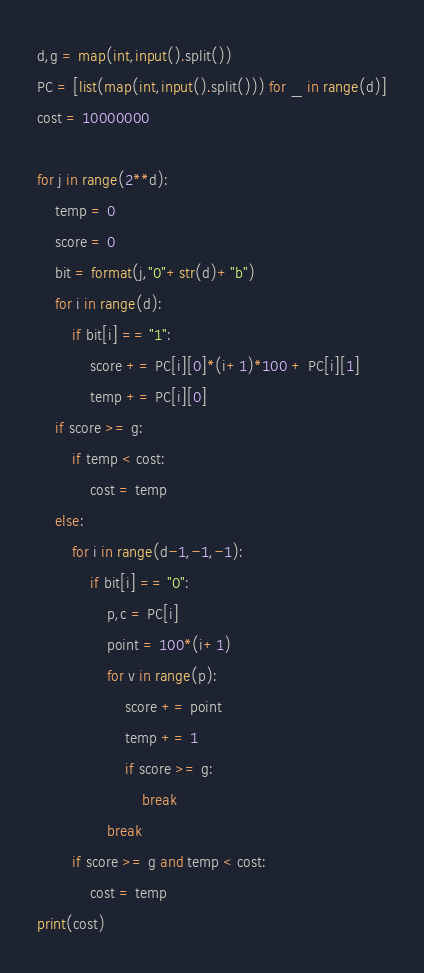Convert code to text. <code><loc_0><loc_0><loc_500><loc_500><_Python_>d,g = map(int,input().split())
PC = [list(map(int,input().split())) for _ in range(d)]
cost = 10000000

for j in range(2**d):
    temp = 0
    score = 0
    bit = format(j,"0"+str(d)+"b")
    for i in range(d):
        if bit[i] == "1":
            score += PC[i][0]*(i+1)*100 + PC[i][1]
            temp += PC[i][0]
    if score >= g:
        if temp < cost:
            cost = temp
    else:
        for i in range(d-1,-1,-1):
            if bit[i] == "0":
                p,c = PC[i]
                point = 100*(i+1)
                for v in range(p):
                    score += point
                    temp += 1
                    if score >= g:
                        break
                break
        if score >= g and temp < cost:
            cost = temp
print(cost)</code> 